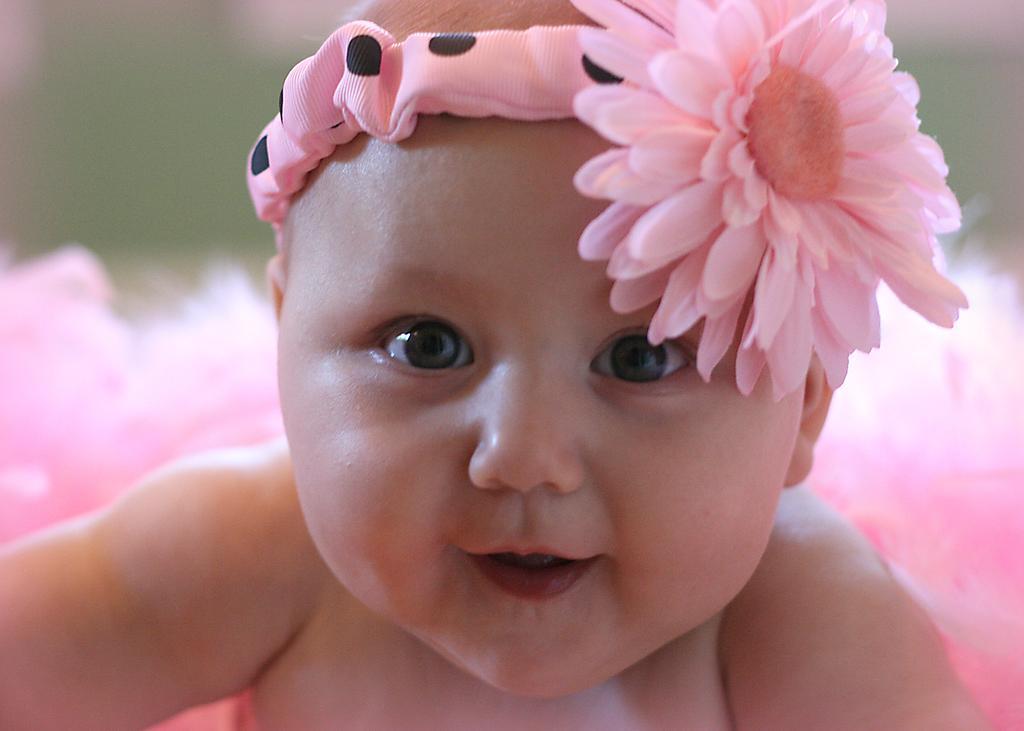Could you give a brief overview of what you see in this image? In this image, I can see a baby smiling. This baby wore a headband with a flower, which is pink in color. The background looks blurry. 